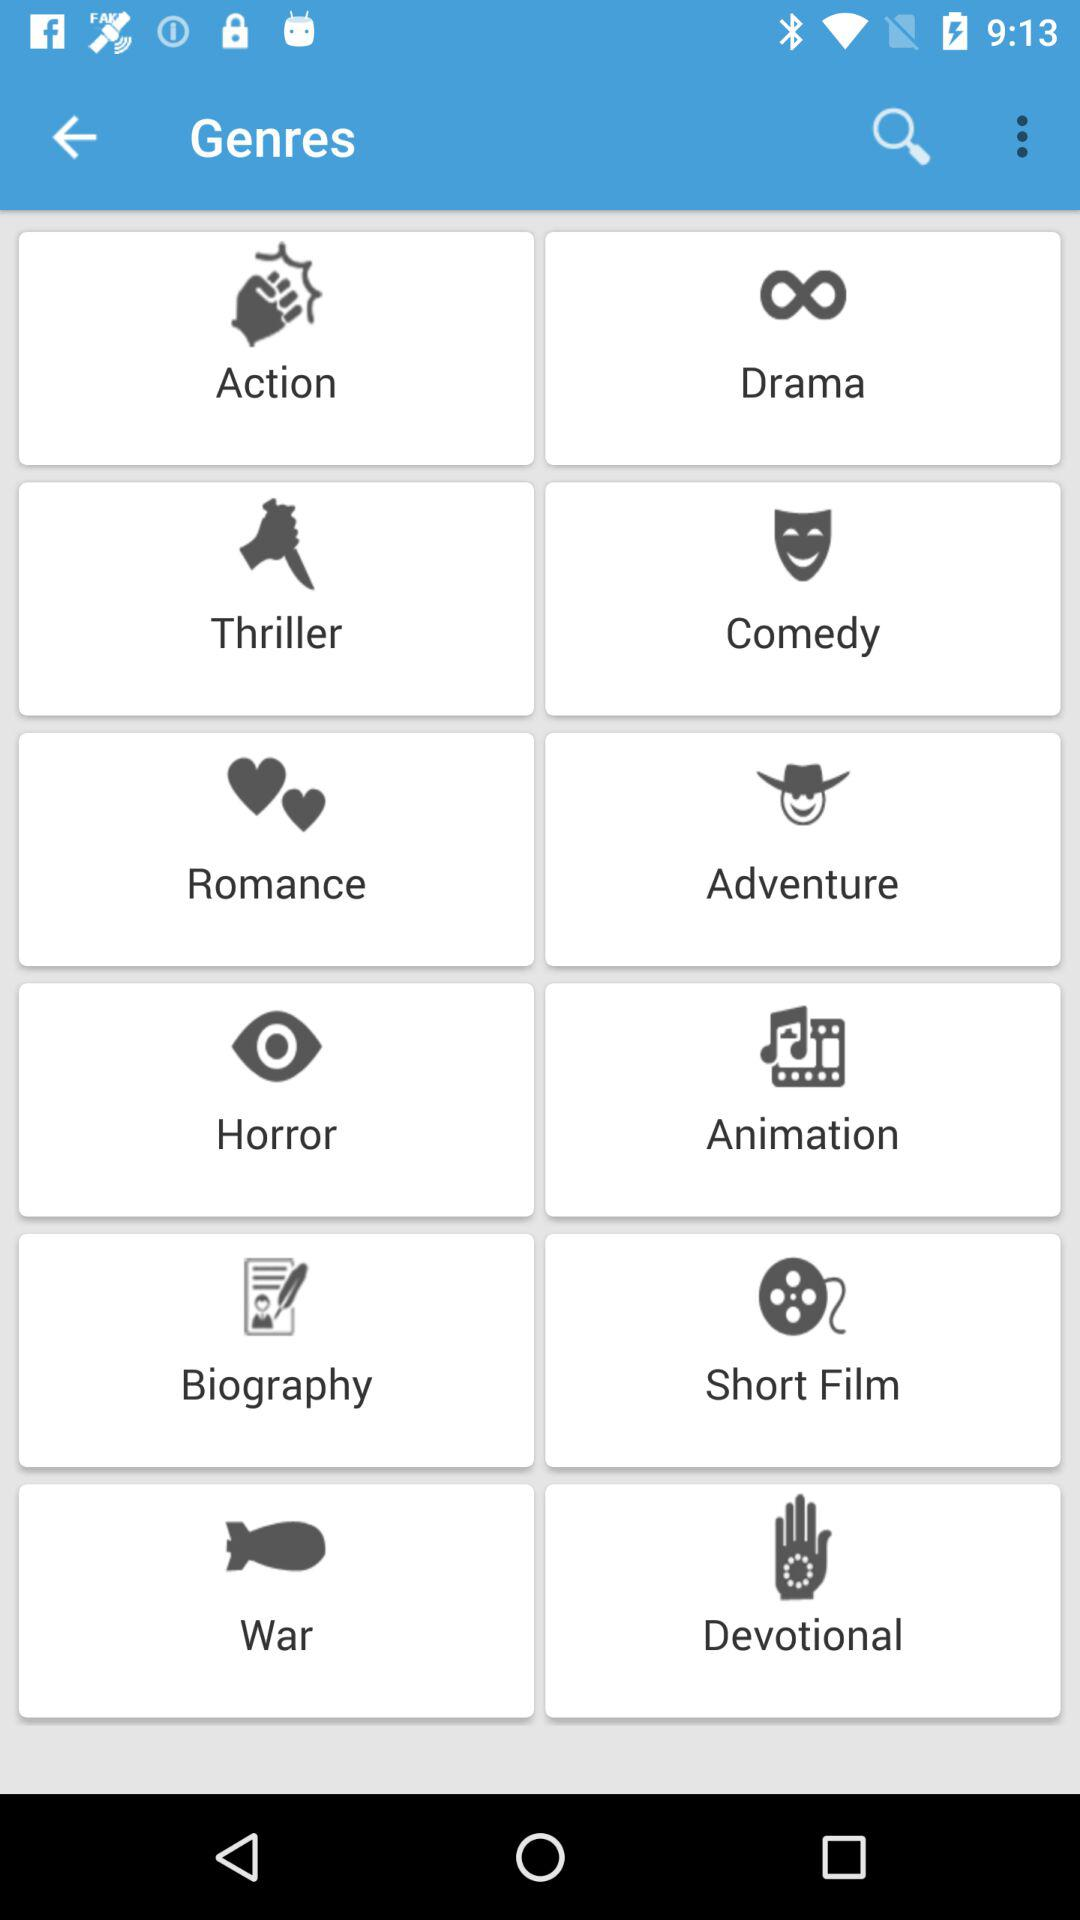What are the different categories of genres available? The different categories of genre are "Action", "Drama", "Thriller", "Comedy", "Romance", "Adventure", "Horror", "Animation", "Biography", "Short Film", "War" and "Devotional". 